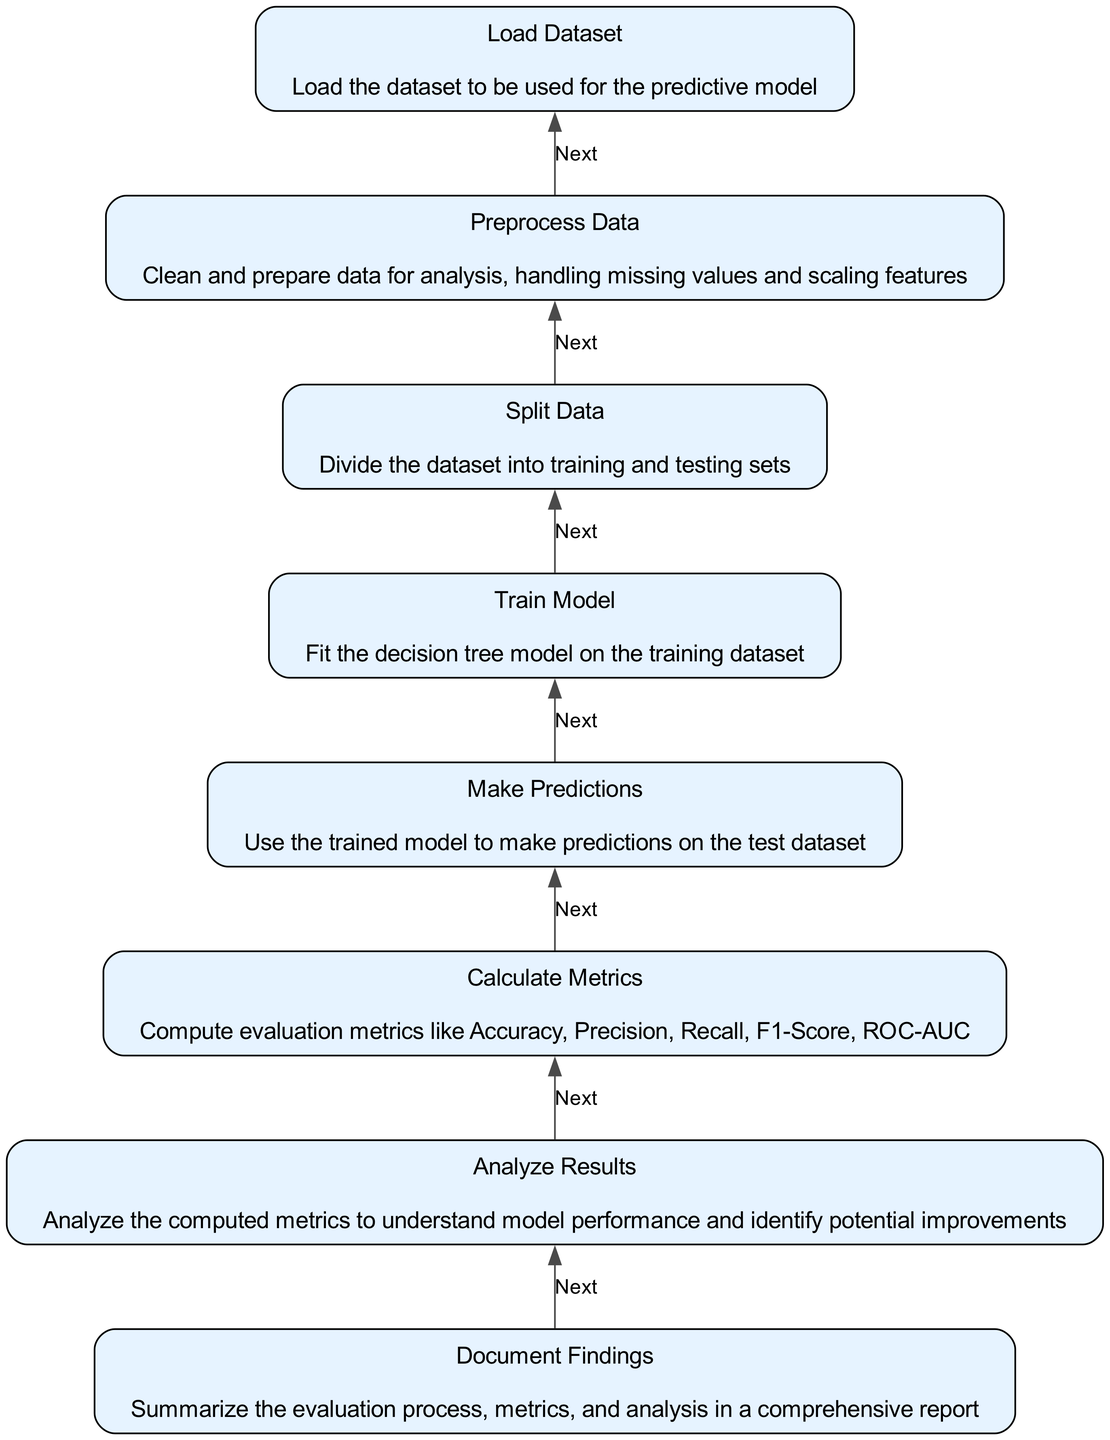what is the first step in the predictive model evaluation process? The first step, as indicated in the diagram, is "Load Dataset". This can be observed at the bottom of the flow, representing the initiation of the process.
Answer: Load Dataset how many nodes are present in the diagram? The diagram contains a total of eight nodes. By counting each element listed in the data provided, we see that they are sequentially connected from "Load Dataset" to "Document Findings".
Answer: Eight which step follows 'Make Predictions'? After 'Make Predictions', the next step is 'Calculate Metrics'. You can see this directly from the flow as "Make Predictions" leads to "Calculate Metrics".
Answer: Calculate Metrics what are the evaluation metrics calculated in this process? The evaluation metrics calculated in this process include Accuracy, Precision, Recall, F1-Score, and ROC-AUC. This is mentioned specifically in the description of the "Calculate Metrics" step.
Answer: Accuracy, Precision, Recall, F1-Score, ROC-AUC what is the relationship between 'Preprocess Data' and 'Load Dataset'? The relationship between 'Preprocess Data' and 'Load Dataset' is that 'Preprocess Data' is the direct next step following 'Load Dataset'. This establishes an ordered flow from loading to preparing the data.
Answer: Next step why is 'Analyze Results' important in the evaluation process? 'Analyze Results' is crucial because it allows for an in-depth examination of the computed metrics, helping to understand model performance and identify potential improvements. This connects the analysis to actionable insights which is critical in model development.
Answer: Understanding performance how does the flow chart represent the model evaluation process? The flow chart visually represents the model evaluation process by organizing each step in sequential order from the bottom to the top, portraying a clear progression through data handling, modeling, predicting, evaluating, and documenting findings.
Answer: Sequential steps which step includes summarizing the evaluation process? The step that includes summarizing the evaluation process is 'Document Findings'. This is noted as the final step in the evaluation process, indicating its importance for reporting.
Answer: Document Findings 